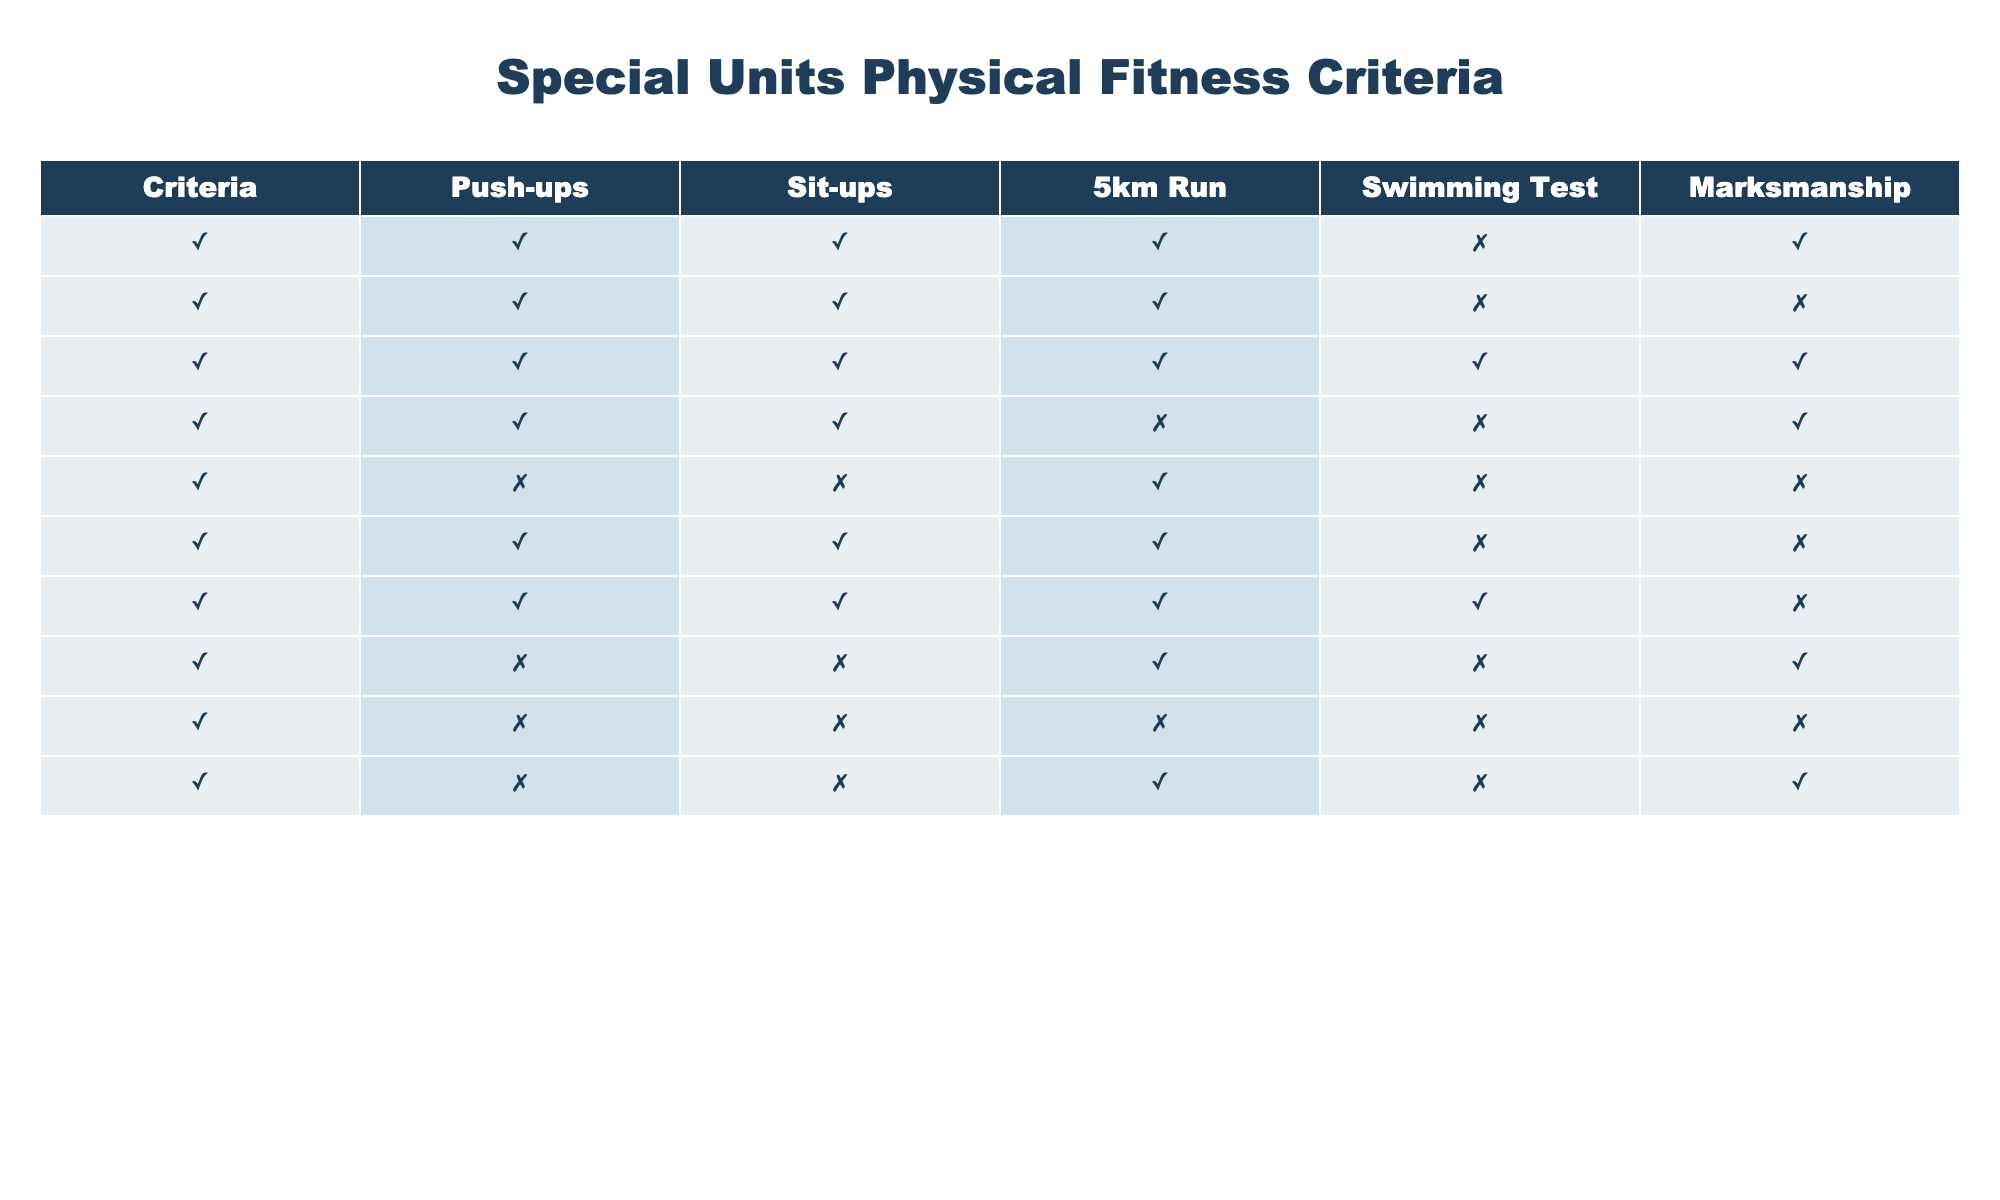What special units require push-ups as a fitness criterion? Referring to the table, I look for the 'Push-ups' column where the value is TRUE. The units that qualify are SWAT Qualification, K-9 Unit Eligibility, Tactical Response Team, Bomb Squad Fitness, Mounted Police Unit, and Marine Patrol Fitness.
Answer: SWAT Qualification, K-9 Unit Eligibility, Tactical Response Team, Bomb Squad Fitness, Mounted Police Unit, Marine Patrol Fitness Is swimming test a requirement for the Tactical Response Team? I examine the 'Swimming Test' column specifically for the Tactical Response Team row. The value here is TRUE, indicating it is a requirement.
Answer: Yes How many units require both sit-ups and marksmanship? I check the rows where both 'Sit-ups' and 'Marksmanship' are TRUE. By reviewing the table, I find the following units: SWAT Qualification, Tactical Response Team, and Bomb Squad Fitness. This totals three units.
Answer: 3 For which units is swimming test not required? I look at the 'Swimming Test' column and filter for FALSE values. The units with no swimming test requirement include SWAT Qualification, K-9 Unit Eligibility, Bomb Squad Fitness, Hostage Negotiation Team, Mounted Police Unit, and Air Support Unit. There are six units in total.
Answer: 6 Do any units require all physical fitness criteria? I check all rows to see if there is any unit where all five criteria (Push-ups, Sit-ups, 5km Run, Swimming Test, Marksmanship) have TRUE values. This is only true for the Tactical Response Team.
Answer: Yes Which unit has the least number of fitness requirements? I analyze the fitness requirements for each unit by counting the number of TRUE values in each row. The Crime Scene Investigation unit meets none of the criteria (all FALSE). This unit, therefore, has the least number of requirements.
Answer: Crime Scene Investigation Is there a unit that requires no physical fitness criteria at all? I inspect the table for any unit with no TRUE values across all fitness criteria. The Crime Scene Investigation unit has no requirements, as it shows all FALSE values in the table.
Answer: Yes What percentage of units require the 5km run? First, I count the total number of units, which is 10. Then, I identify how many units require the 5km run by checking the TRUE values in the corresponding column. These are SWAT Qualification, K-9 Unit Eligibility, Tactical Response Team, Mounted Police Unit, Marine Patrol Fitness, Air Support Unit, and Undercover Operations, summing up to 7 units. The percentage is (7/10) * 100 = 70%.
Answer: 70% 